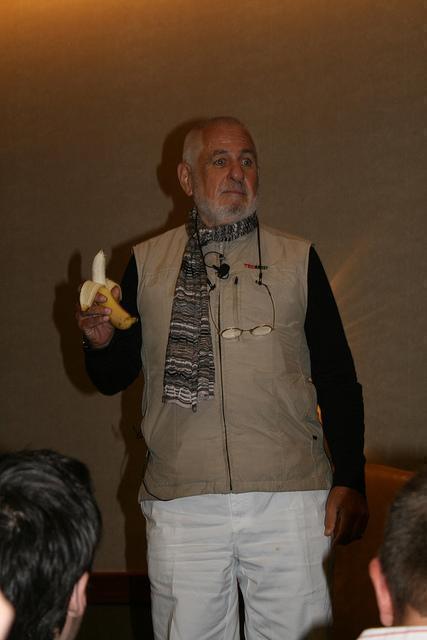What type of eyesight does the man standing here have?
Choose the correct response, then elucidate: 'Answer: answer
Rationale: rationale.'
Options: 2020, near sighted, perfect, far sighted. Answer: far sighted.
Rationale: The man has glasses around his neck. 